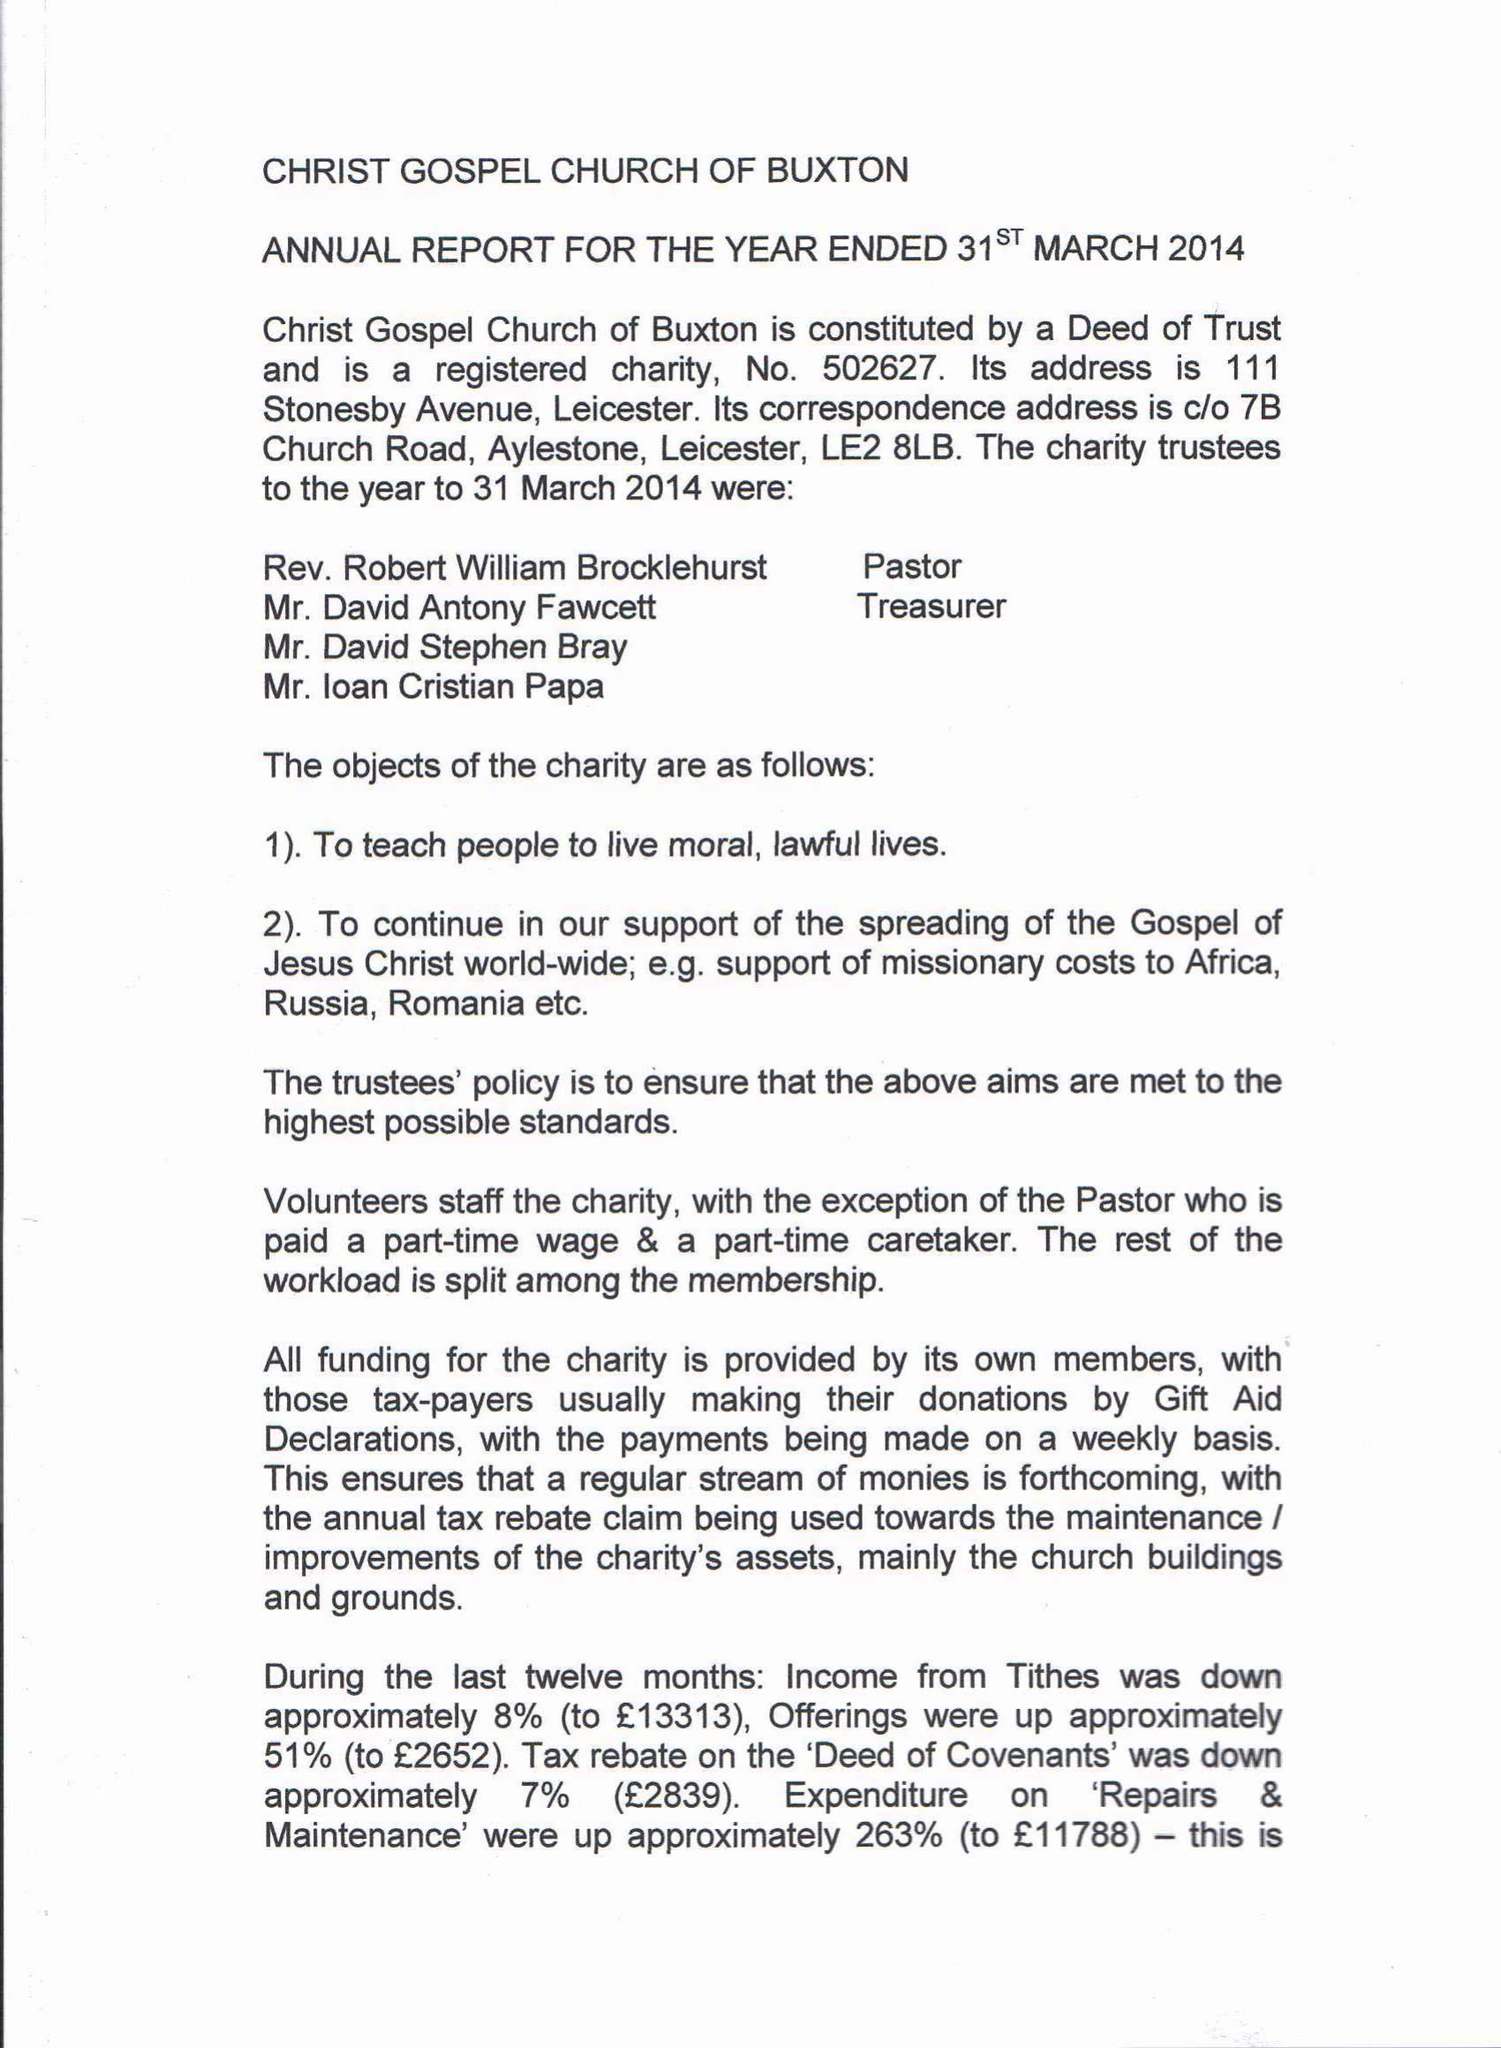What is the value for the charity_name?
Answer the question using a single word or phrase. Christ Gospel Church 